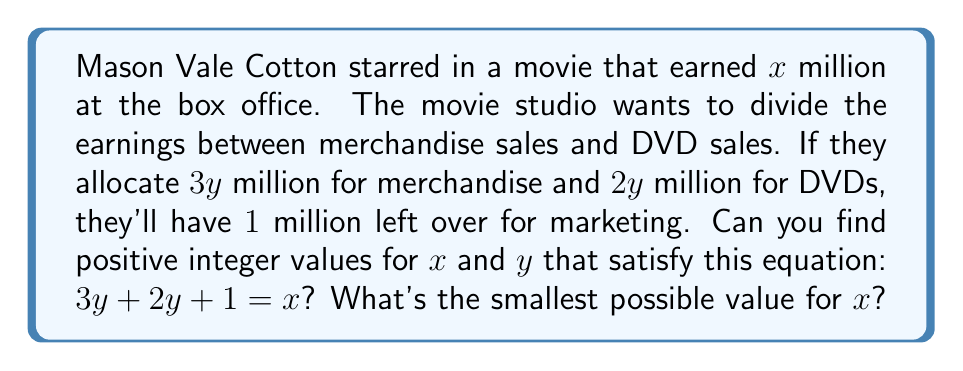Teach me how to tackle this problem. Let's approach this step-by-step:

1) First, we need to simplify the equation:
   $3y + 2y + 1 = x$
   $5y + 1 = x$

2) This is a linear Diophantine equation in the form:
   $5y - x = -1$

3) For this equation to have integer solutions, the greatest common divisor (GCD) of the coefficients of $y$ and $x$ must divide the constant term. In this case:
   $GCD(5, -1) = 1$, which divides $-1$

4) Therefore, this equation has infinitely many integer solutions.

5) The general solution for this equation is:
   $y = 1 + t$
   $x = 5 + 5t$
   where $t$ is any integer.

6) Since we're looking for positive integer values, $t$ must be a non-negative integer.

7) The smallest possible value for $x$ will occur when $t = 0$:
   $y = 1 + 0 = 1$
   $x = 5 + 5(0) = 5$

8) We can verify: $3(1) + 2(1) + 1 = 3 + 2 + 1 = 6 = 5 + 1 = x$

Therefore, the smallest possible value for $x$ is 5 million dollars.
Answer: The smallest possible value for $x$ is $5$ million dollars, with $y = 1$ million dollars. 